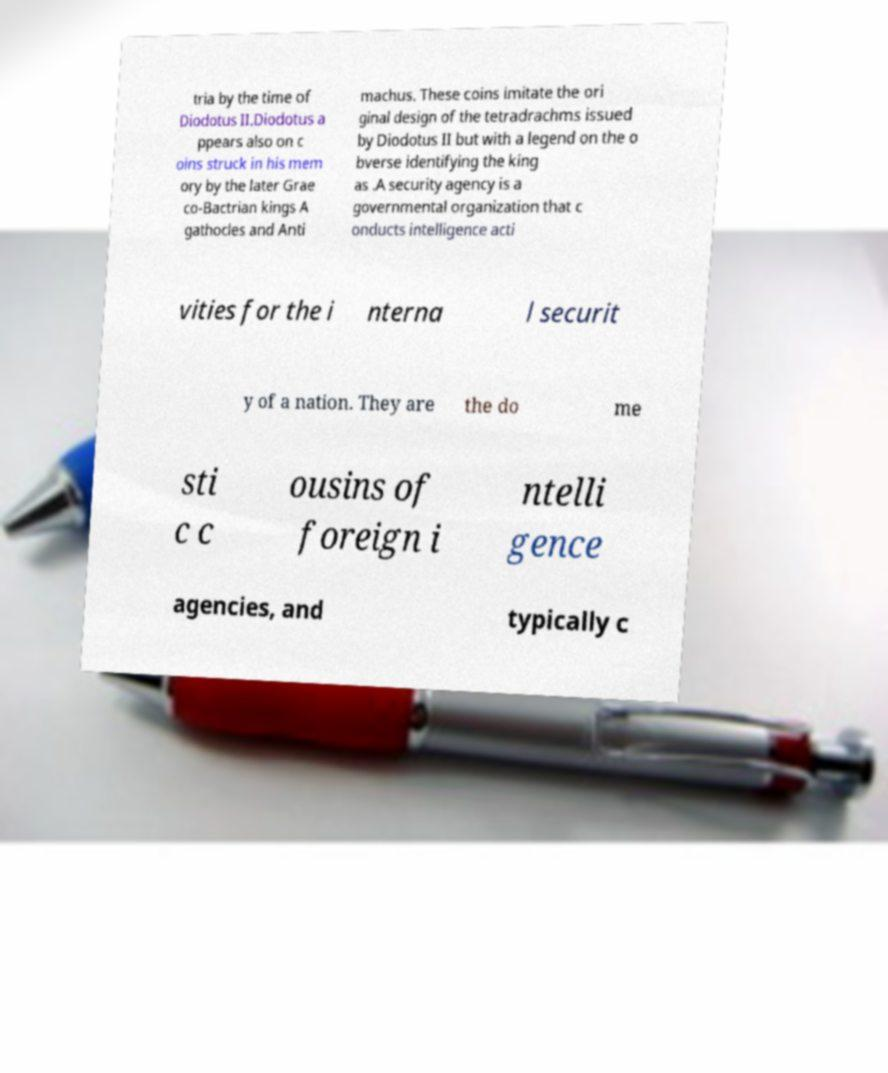There's text embedded in this image that I need extracted. Can you transcribe it verbatim? tria by the time of Diodotus II.Diodotus a ppears also on c oins struck in his mem ory by the later Grae co-Bactrian kings A gathocles and Anti machus. These coins imitate the ori ginal design of the tetradrachms issued by Diodotus II but with a legend on the o bverse identifying the king as .A security agency is a governmental organization that c onducts intelligence acti vities for the i nterna l securit y of a nation. They are the do me sti c c ousins of foreign i ntelli gence agencies, and typically c 